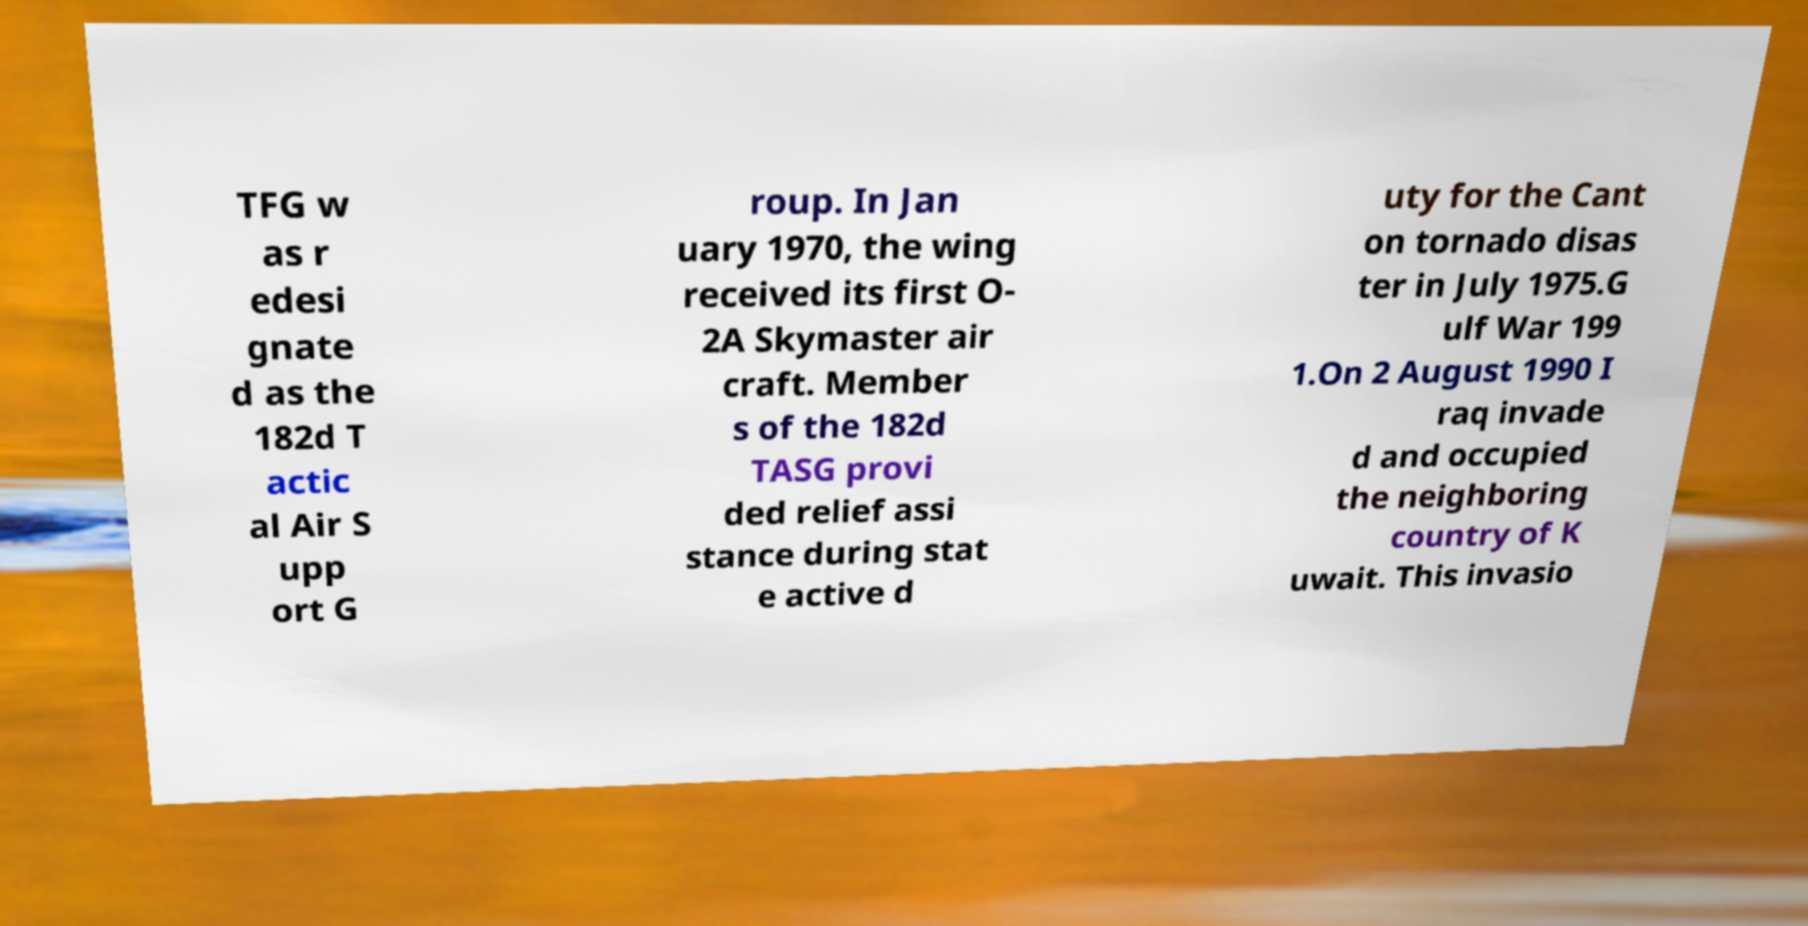For documentation purposes, I need the text within this image transcribed. Could you provide that? TFG w as r edesi gnate d as the 182d T actic al Air S upp ort G roup. In Jan uary 1970, the wing received its first O- 2A Skymaster air craft. Member s of the 182d TASG provi ded relief assi stance during stat e active d uty for the Cant on tornado disas ter in July 1975.G ulf War 199 1.On 2 August 1990 I raq invade d and occupied the neighboring country of K uwait. This invasio 